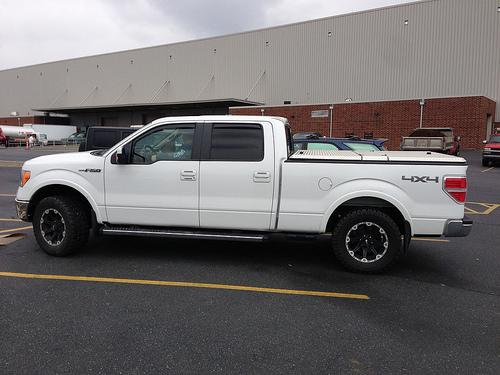List any notable features about the truck's wheels or tires. The truck has a large black front tire and a white rim on the back tire. Identify the primary vehicle in the picture and its color. The primary vehicle is a white 4x4 pickup truck. How would you describe the location where the vehicles are parked? The vehicles are parked in a lot beside an industrial building with an asphalt road nearby. What is the atmospheric condition based on the image? The sky appears to be grey and cloudy. Explain any unique features on the building in the image. The building has a tall gray and brown color, a brick wall, a row of poles, and a large metal awning suspended by poles. Mention any other vehicles present in the image and their colors. There is a parked blue car, a parked black car, and a parked red truck. Which parts of the truck are obstructed from view in the image? The front of the truck and the driver's side are obstructed from view. Provide a short description of the person inside the truck. The person sitting in the truck is partially visible through the window. Describe any specific modifications you can see on the truck. The truck has an extended cab, tinted rear side window, door handles, and a metal bed cover. What objects mark the parking spaces in the lot? Yellow lines and an orange traffic cone mark the parking spaces. 